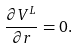<formula> <loc_0><loc_0><loc_500><loc_500>\frac { \partial V ^ { L } } { \partial r } = 0 .</formula> 